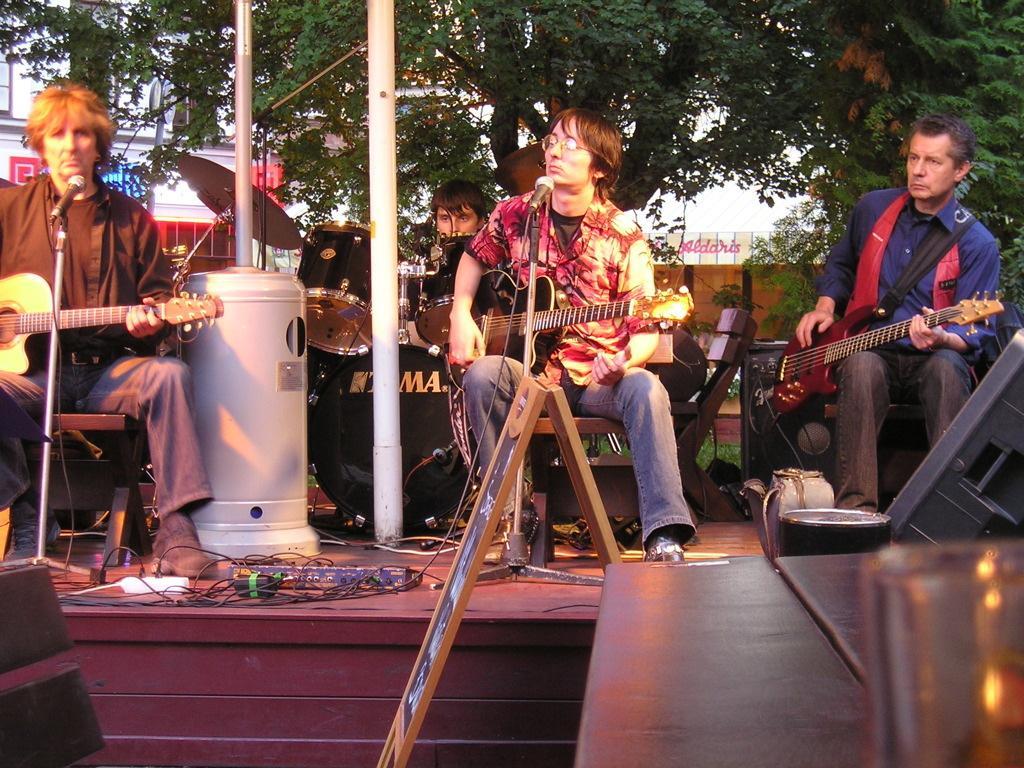How would you summarize this image in a sentence or two? It is a concert there are total four people on the stage three of them are playing the guitar and one person who is sitting behind is playing drums ,in the background there is the set top dish, behind that there is a big tree to the left side there is a building to the right side there is a board and a wall. 